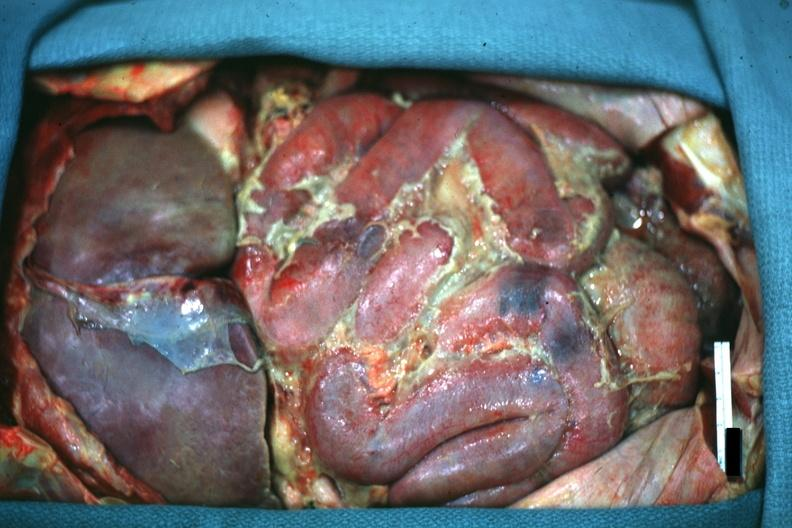s subdiaphragmatic abscess present?
Answer the question using a single word or phrase. No 